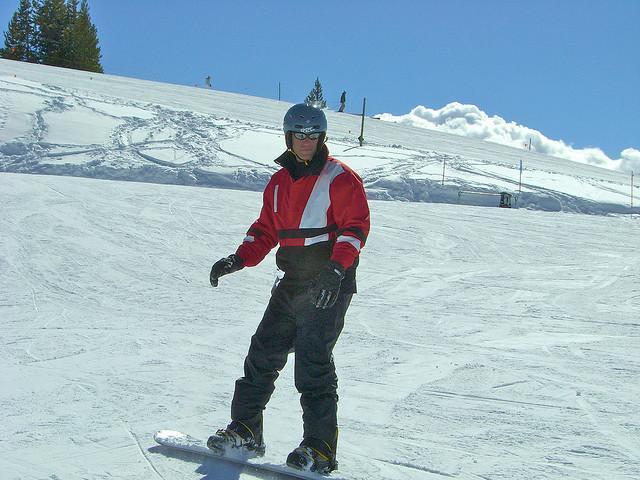How many red double decker buses are in the image?
Give a very brief answer. 0. 